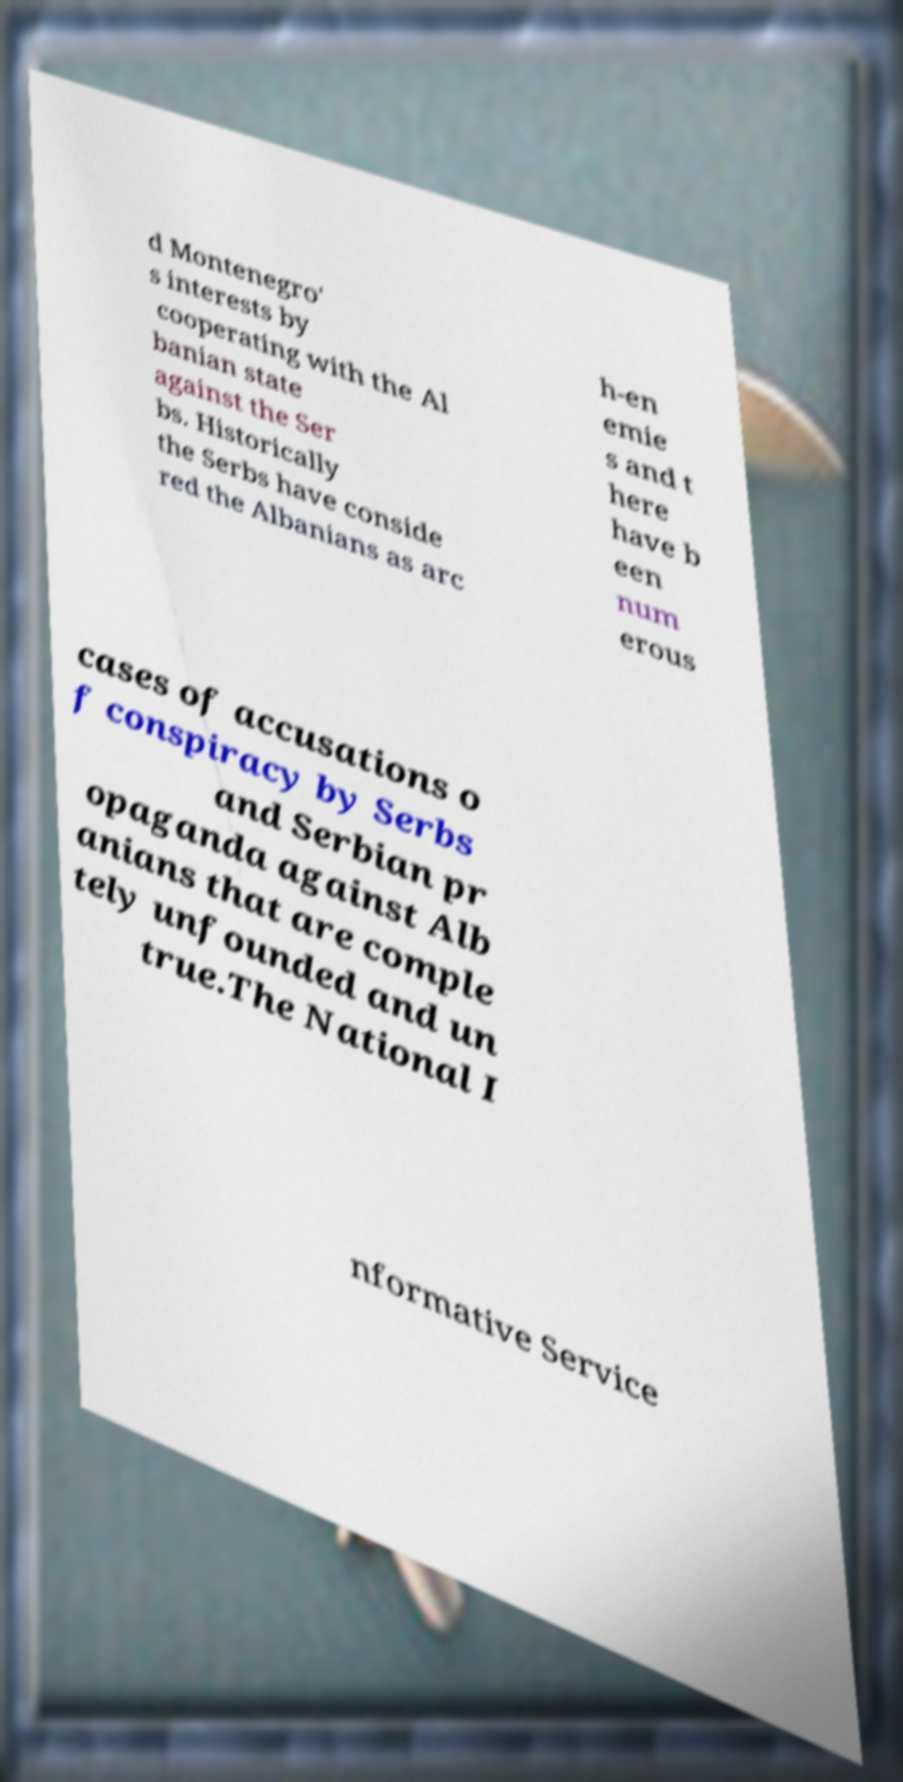There's text embedded in this image that I need extracted. Can you transcribe it verbatim? d Montenegro' s interests by cooperating with the Al banian state against the Ser bs. Historically the Serbs have conside red the Albanians as arc h-en emie s and t here have b een num erous cases of accusations o f conspiracy by Serbs and Serbian pr opaganda against Alb anians that are comple tely unfounded and un true.The National I nformative Service 